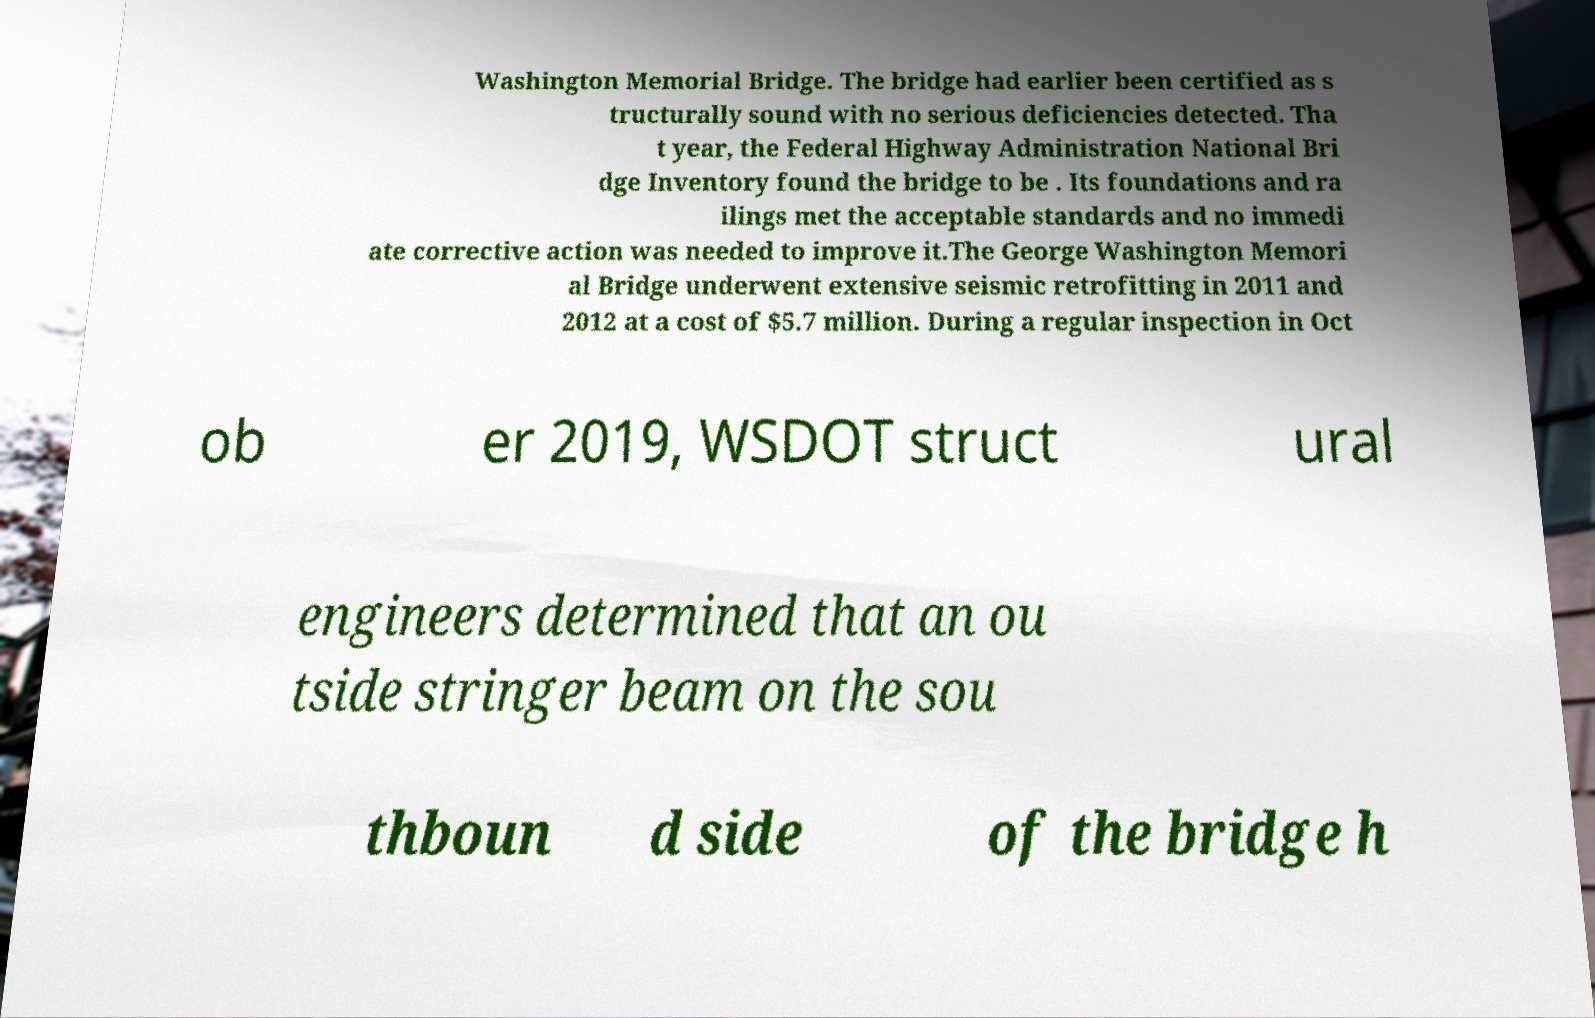Could you assist in decoding the text presented in this image and type it out clearly? Washington Memorial Bridge. The bridge had earlier been certified as s tructurally sound with no serious deficiencies detected. Tha t year, the Federal Highway Administration National Bri dge Inventory found the bridge to be . Its foundations and ra ilings met the acceptable standards and no immedi ate corrective action was needed to improve it.The George Washington Memori al Bridge underwent extensive seismic retrofitting in 2011 and 2012 at a cost of $5.7 million. During a regular inspection in Oct ob er 2019, WSDOT struct ural engineers determined that an ou tside stringer beam on the sou thboun d side of the bridge h 